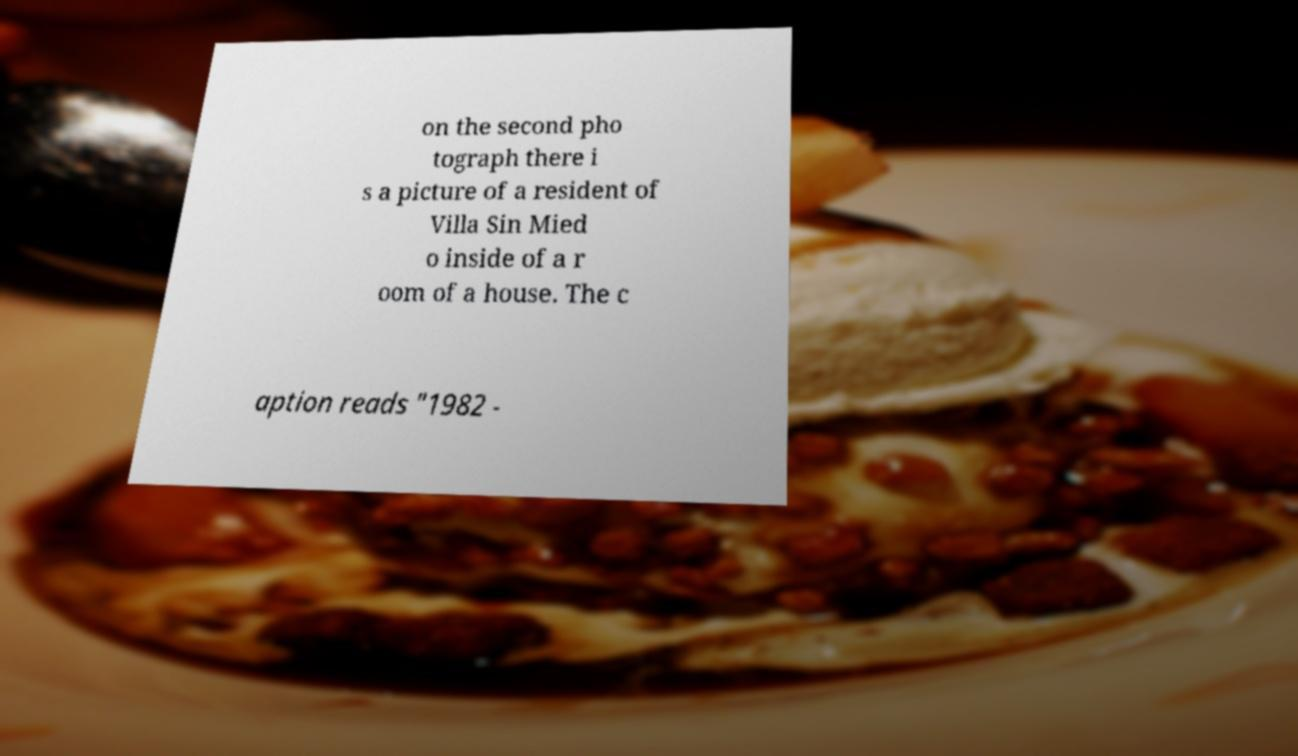What messages or text are displayed in this image? I need them in a readable, typed format. on the second pho tograph there i s a picture of a resident of Villa Sin Mied o inside of a r oom of a house. The c aption reads "1982 - 